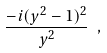<formula> <loc_0><loc_0><loc_500><loc_500>\frac { - i ( y ^ { 2 } - 1 ) ^ { 2 } } { y ^ { 2 } } \ ,</formula> 